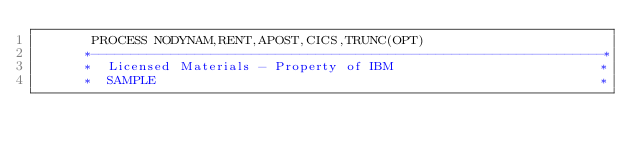Convert code to text. <code><loc_0><loc_0><loc_500><loc_500><_COBOL_>       PROCESS NODYNAM,RENT,APOST,CICS,TRUNC(OPT)
      *----------------------------------------------------------------*
      *  Licensed Materials - Property of IBM                          *
      *  SAMPLE                                                        *</code> 